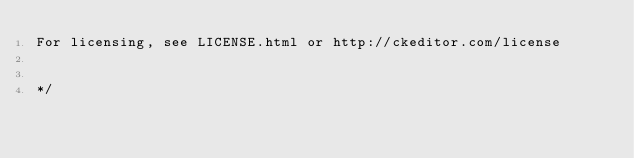<code> <loc_0><loc_0><loc_500><loc_500><_CSS_>For licensing, see LICENSE.html or http://ckeditor.com/license


*/

</code> 